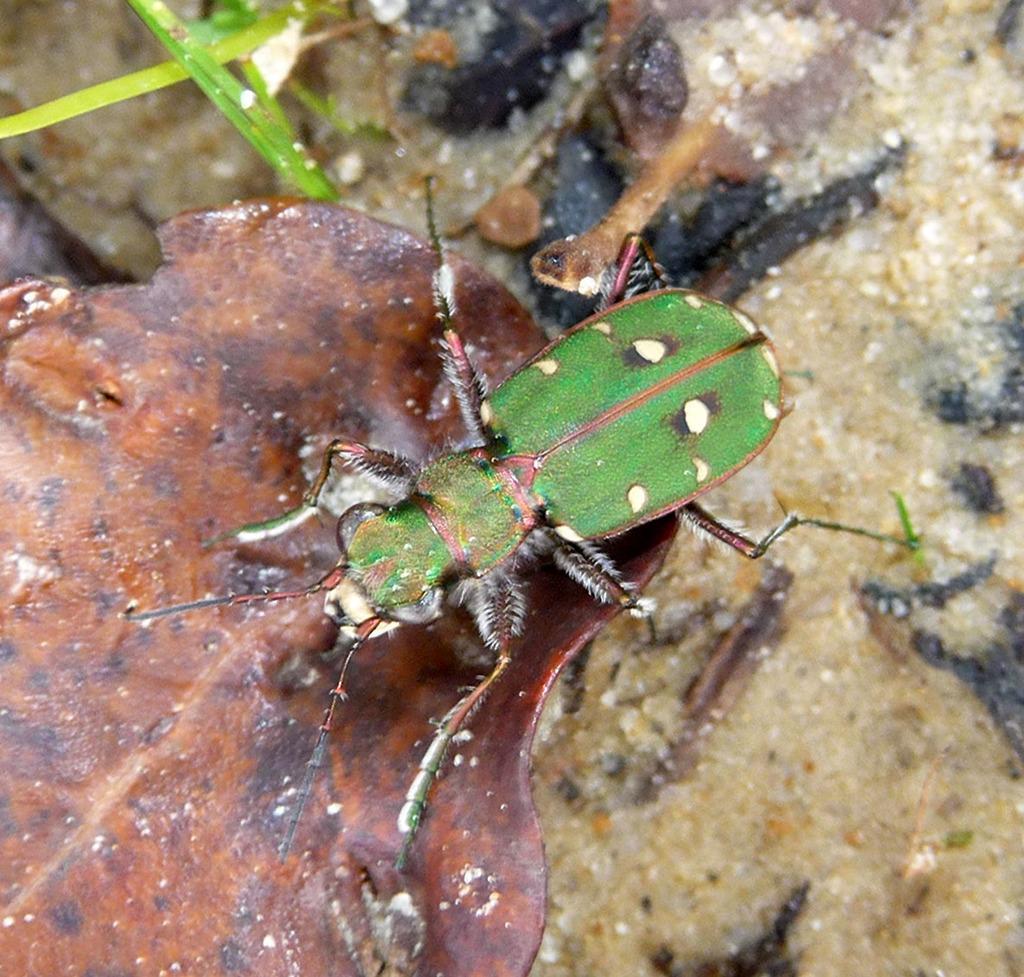In one or two sentences, can you explain what this image depicts? This is the picture of the insect on the leaf. 